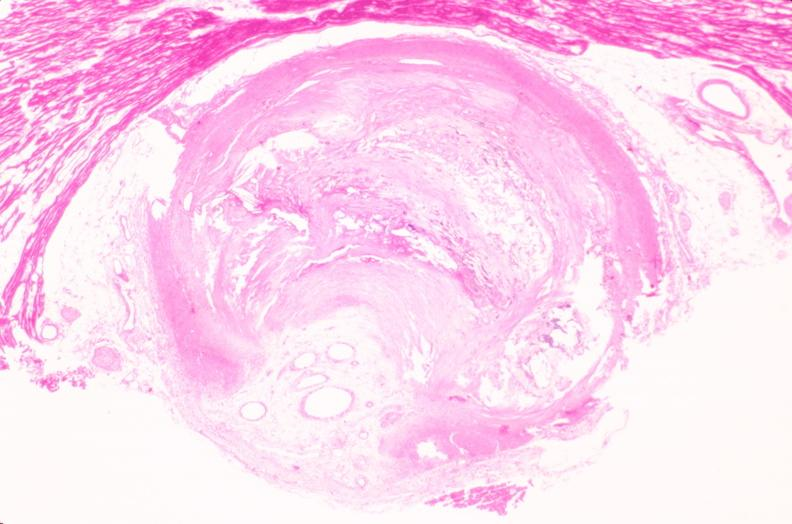does this image show coronary artery atherosclerosis?
Answer the question using a single word or phrase. Yes 